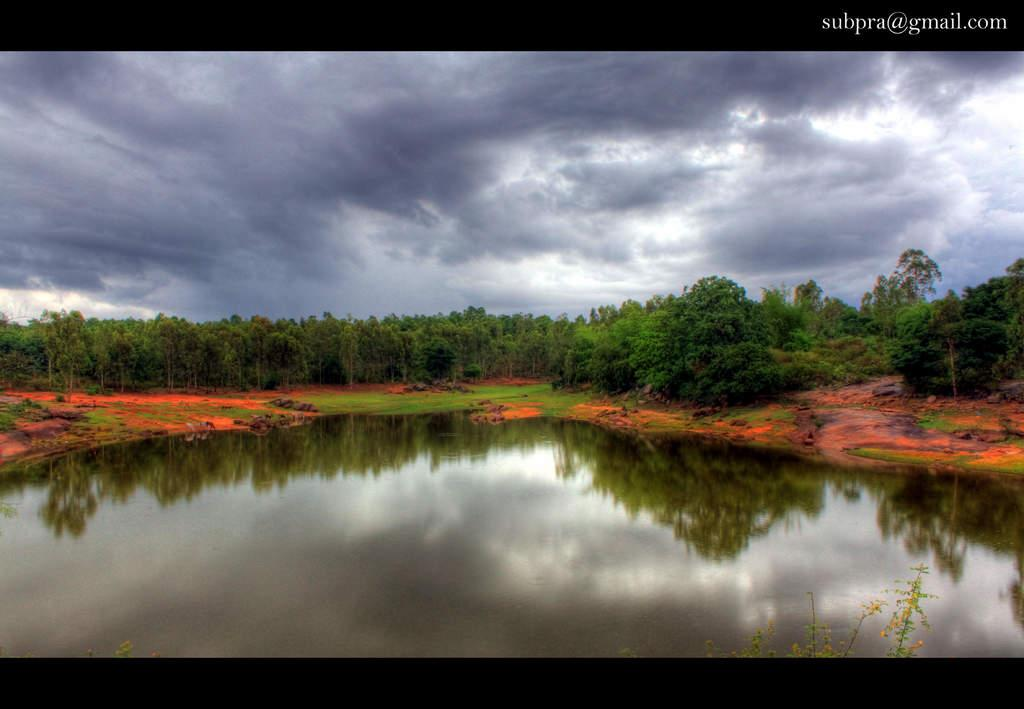What is the primary element visible in the image? There is water in the image. What type of vegetation can be seen in the background of the image? There is grass and trees in the background of the image. What is visible in the sky in the image? The sky is visible in the background of the image, and there are clouds present. Can you describe the watermark in the image? There is a watermark in the right top corner of the image. What type of feast is being prepared in the image? There is no indication of a feast or any food preparation in the image. 